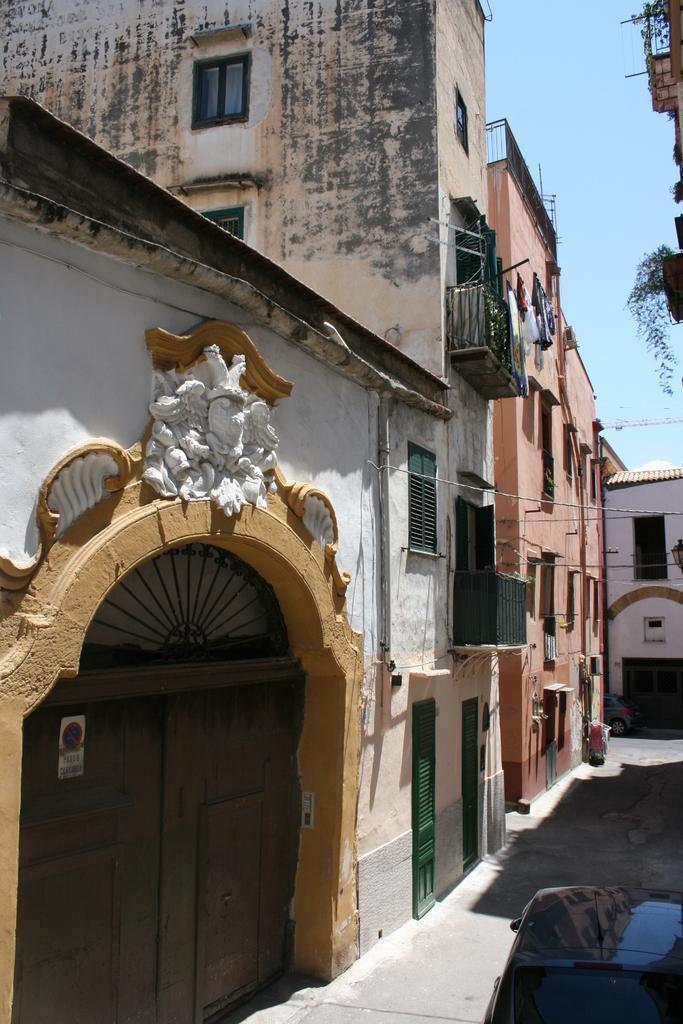Please provide a concise description of this image. In this picture we can see few buildings, cables and vehicles, on the left side of the image we can see a poster on the door. 